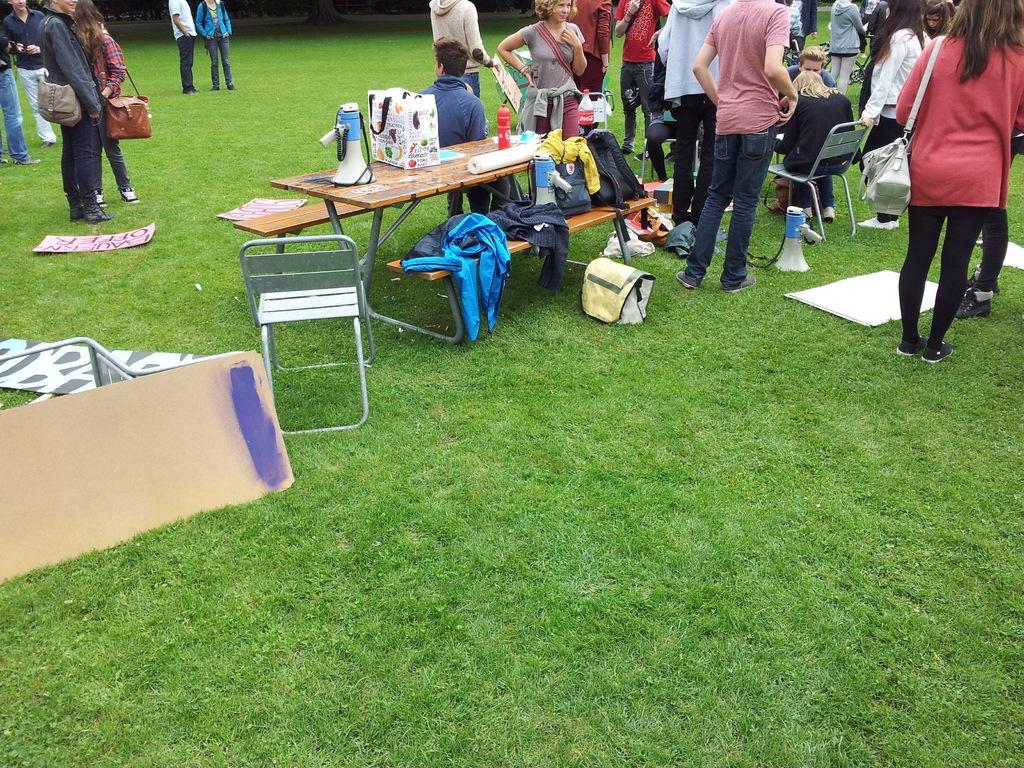How would you summarize this image in a sentence or two? In this image in the center there are some tables and chairs, on the tables there are some bags, papers, speaker and some clothes. And also there are some people who are sitting on chairs and some people are standing and some of them are wearing bags, at the bottom there is a grass. On the grass there are some bags, clothes, speakers and some boards. 